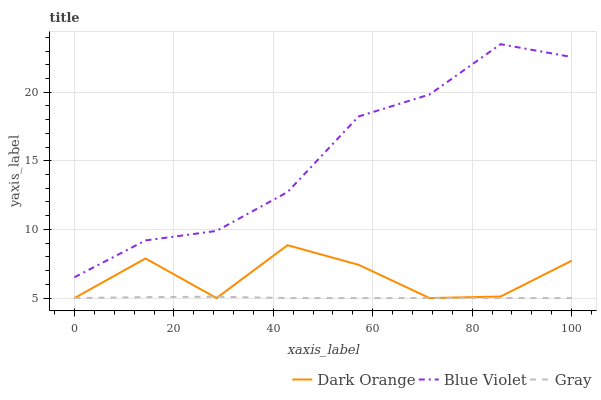Does Gray have the minimum area under the curve?
Answer yes or no. Yes. Does Blue Violet have the maximum area under the curve?
Answer yes or no. Yes. Does Blue Violet have the minimum area under the curve?
Answer yes or no. No. Does Gray have the maximum area under the curve?
Answer yes or no. No. Is Gray the smoothest?
Answer yes or no. Yes. Is Dark Orange the roughest?
Answer yes or no. Yes. Is Blue Violet the smoothest?
Answer yes or no. No. Is Blue Violet the roughest?
Answer yes or no. No. Does Dark Orange have the lowest value?
Answer yes or no. Yes. Does Blue Violet have the lowest value?
Answer yes or no. No. Does Blue Violet have the highest value?
Answer yes or no. Yes. Does Gray have the highest value?
Answer yes or no. No. Is Dark Orange less than Blue Violet?
Answer yes or no. Yes. Is Blue Violet greater than Dark Orange?
Answer yes or no. Yes. Does Gray intersect Dark Orange?
Answer yes or no. Yes. Is Gray less than Dark Orange?
Answer yes or no. No. Is Gray greater than Dark Orange?
Answer yes or no. No. Does Dark Orange intersect Blue Violet?
Answer yes or no. No. 